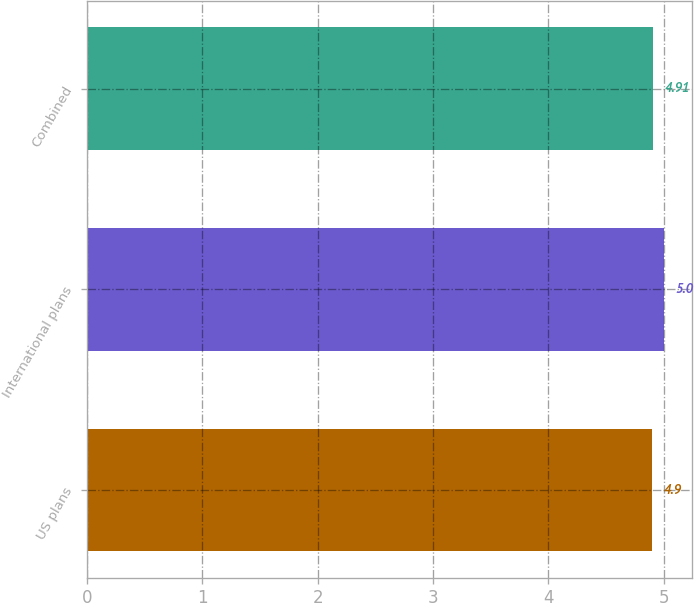<chart> <loc_0><loc_0><loc_500><loc_500><bar_chart><fcel>US plans<fcel>International plans<fcel>Combined<nl><fcel>4.9<fcel>5<fcel>4.91<nl></chart> 